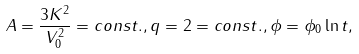<formula> <loc_0><loc_0><loc_500><loc_500>A = \frac { 3 K ^ { 2 } } { V _ { 0 } ^ { 2 } } = c o n s t . , q = 2 = c o n s t . , \phi = \phi _ { 0 } \ln t ,</formula> 